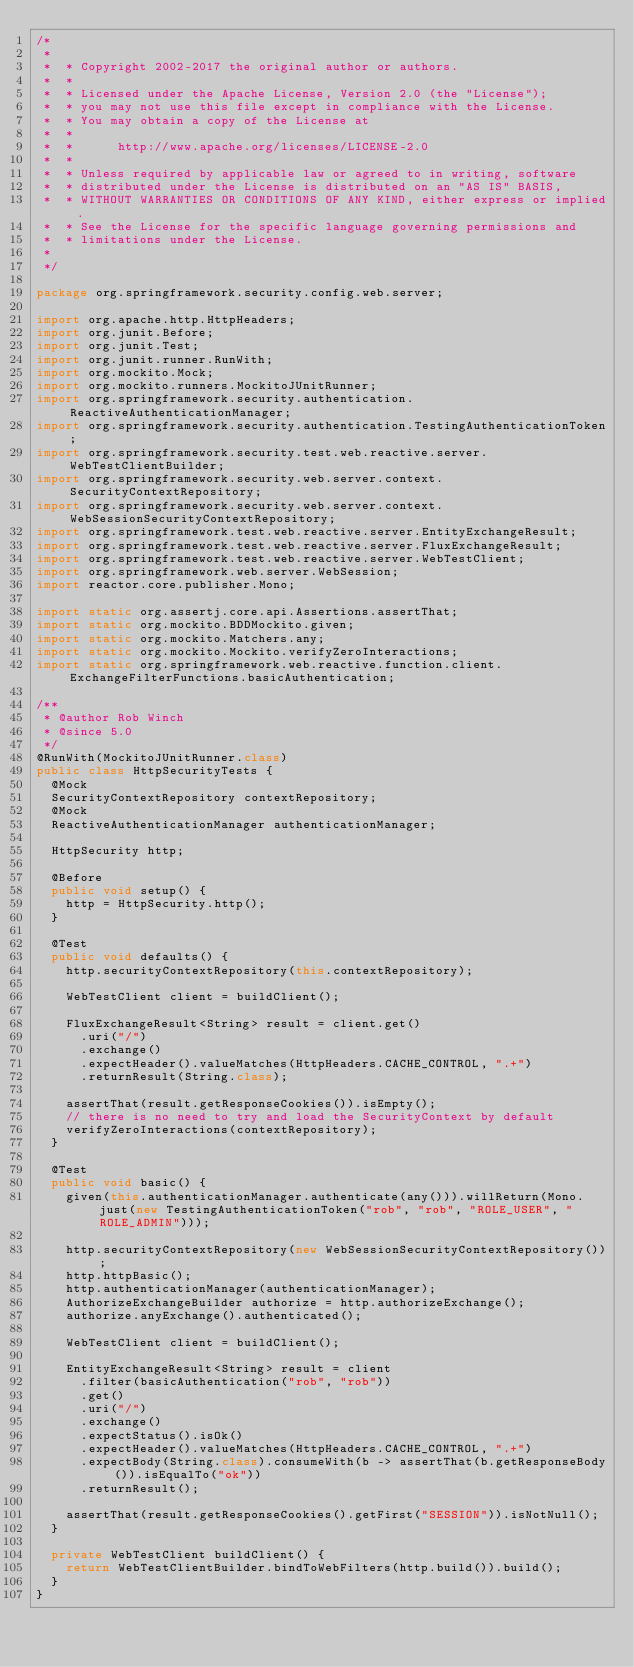<code> <loc_0><loc_0><loc_500><loc_500><_Java_>/*
 *
 *  * Copyright 2002-2017 the original author or authors.
 *  *
 *  * Licensed under the Apache License, Version 2.0 (the "License");
 *  * you may not use this file except in compliance with the License.
 *  * You may obtain a copy of the License at
 *  *
 *  *      http://www.apache.org/licenses/LICENSE-2.0
 *  *
 *  * Unless required by applicable law or agreed to in writing, software
 *  * distributed under the License is distributed on an "AS IS" BASIS,
 *  * WITHOUT WARRANTIES OR CONDITIONS OF ANY KIND, either express or implied.
 *  * See the License for the specific language governing permissions and
 *  * limitations under the License.
 *
 */

package org.springframework.security.config.web.server;

import org.apache.http.HttpHeaders;
import org.junit.Before;
import org.junit.Test;
import org.junit.runner.RunWith;
import org.mockito.Mock;
import org.mockito.runners.MockitoJUnitRunner;
import org.springframework.security.authentication.ReactiveAuthenticationManager;
import org.springframework.security.authentication.TestingAuthenticationToken;
import org.springframework.security.test.web.reactive.server.WebTestClientBuilder;
import org.springframework.security.web.server.context.SecurityContextRepository;
import org.springframework.security.web.server.context.WebSessionSecurityContextRepository;
import org.springframework.test.web.reactive.server.EntityExchangeResult;
import org.springframework.test.web.reactive.server.FluxExchangeResult;
import org.springframework.test.web.reactive.server.WebTestClient;
import org.springframework.web.server.WebSession;
import reactor.core.publisher.Mono;

import static org.assertj.core.api.Assertions.assertThat;
import static org.mockito.BDDMockito.given;
import static org.mockito.Matchers.any;
import static org.mockito.Mockito.verifyZeroInteractions;
import static org.springframework.web.reactive.function.client.ExchangeFilterFunctions.basicAuthentication;

/**
 * @author Rob Winch
 * @since 5.0
 */
@RunWith(MockitoJUnitRunner.class)
public class HttpSecurityTests {
	@Mock
	SecurityContextRepository contextRepository;
	@Mock
	ReactiveAuthenticationManager authenticationManager;

	HttpSecurity http;

	@Before
	public void setup() {
		http = HttpSecurity.http();
	}

	@Test
	public void defaults() {
		http.securityContextRepository(this.contextRepository);

		WebTestClient client = buildClient();

		FluxExchangeResult<String> result = client.get()
			.uri("/")
			.exchange()
			.expectHeader().valueMatches(HttpHeaders.CACHE_CONTROL, ".+")
			.returnResult(String.class);

		assertThat(result.getResponseCookies()).isEmpty();
		// there is no need to try and load the SecurityContext by default
		verifyZeroInteractions(contextRepository);
	}

	@Test
	public void basic() {
		given(this.authenticationManager.authenticate(any())).willReturn(Mono.just(new TestingAuthenticationToken("rob", "rob", "ROLE_USER", "ROLE_ADMIN")));

		http.securityContextRepository(new WebSessionSecurityContextRepository());
		http.httpBasic();
		http.authenticationManager(authenticationManager);
		AuthorizeExchangeBuilder authorize = http.authorizeExchange();
		authorize.anyExchange().authenticated();

		WebTestClient client = buildClient();

		EntityExchangeResult<String> result = client
			.filter(basicAuthentication("rob", "rob"))
			.get()
			.uri("/")
			.exchange()
			.expectStatus().isOk()
			.expectHeader().valueMatches(HttpHeaders.CACHE_CONTROL, ".+")
			.expectBody(String.class).consumeWith(b -> assertThat(b.getResponseBody()).isEqualTo("ok"))
			.returnResult();

		assertThat(result.getResponseCookies().getFirst("SESSION")).isNotNull();
	}

	private WebTestClient buildClient() {
		return WebTestClientBuilder.bindToWebFilters(http.build()).build();
	}
}
</code> 